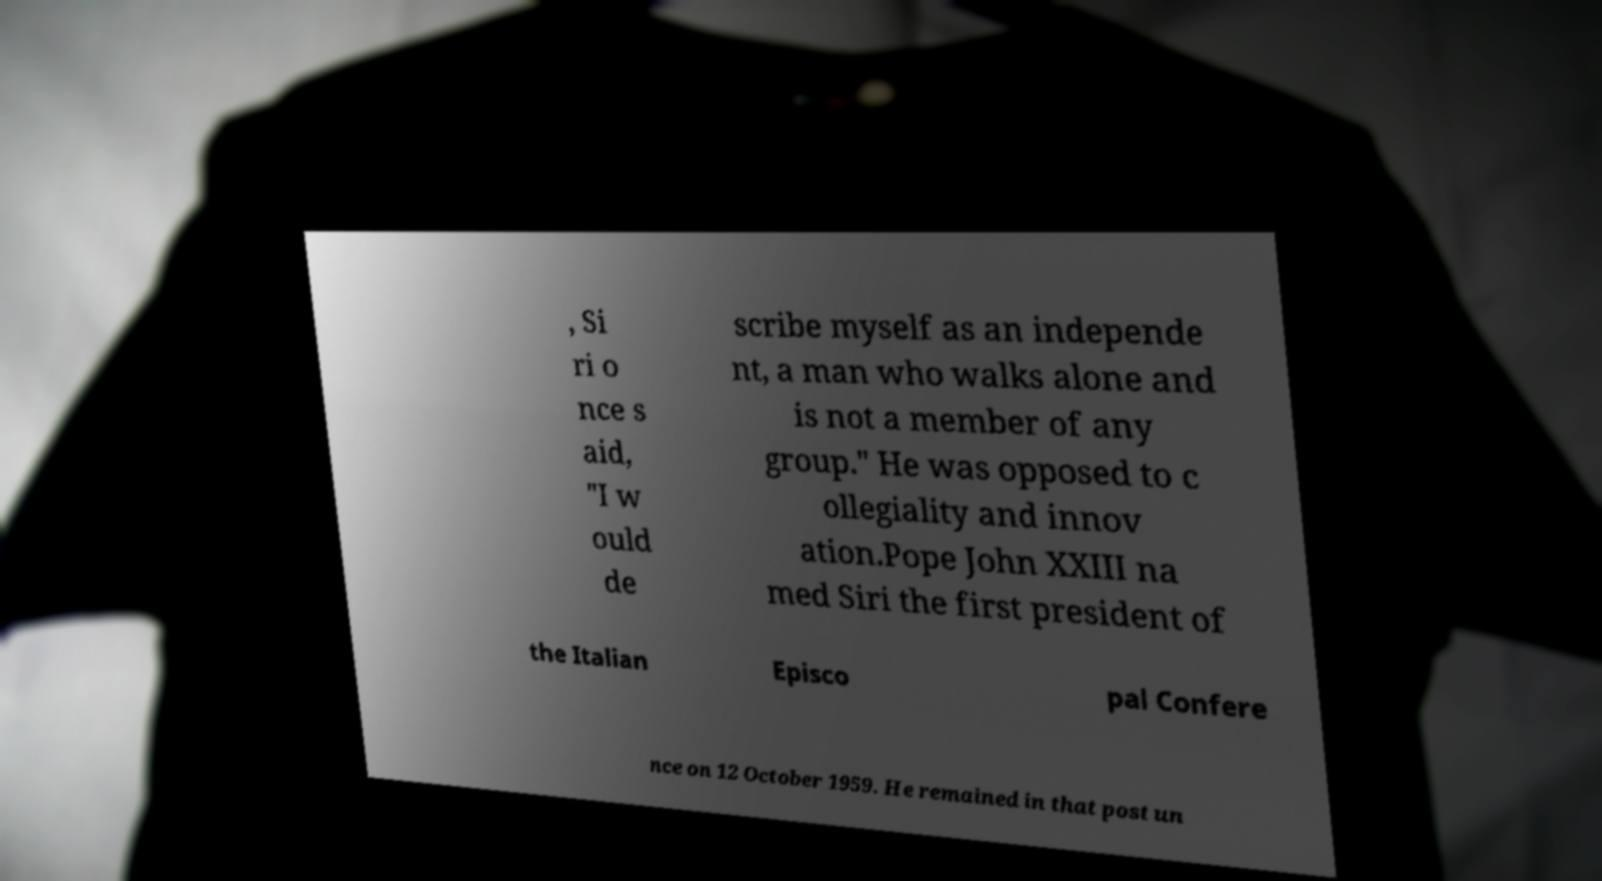There's text embedded in this image that I need extracted. Can you transcribe it verbatim? , Si ri o nce s aid, "I w ould de scribe myself as an independe nt, a man who walks alone and is not a member of any group." He was opposed to c ollegiality and innov ation.Pope John XXIII na med Siri the first president of the Italian Episco pal Confere nce on 12 October 1959. He remained in that post un 